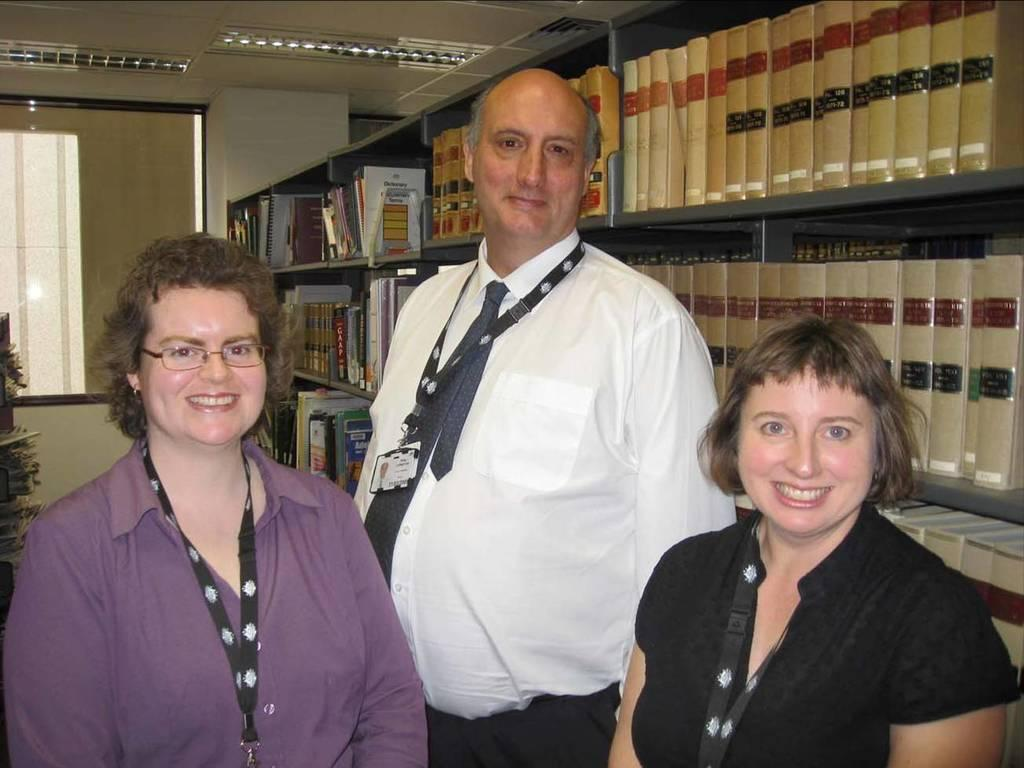How many people are present in the image? There are three persons standing in the image. What can be seen in the background or surrounding the people? Bookshelves are visible in the image. What type of basket is being used to carry the breath in the image? There is no basket or breath present in the image. Can you describe the veins visible on the persons in the image? The image does not show any visible veins on the persons. 